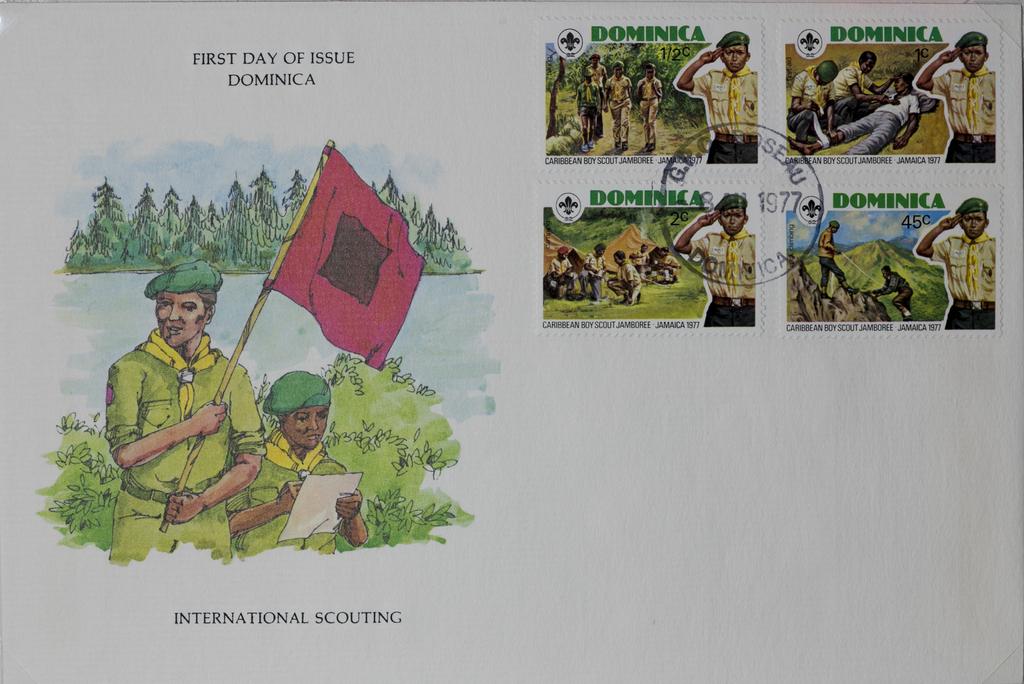Where are those stamps from?
Provide a succinct answer. Dominica. 